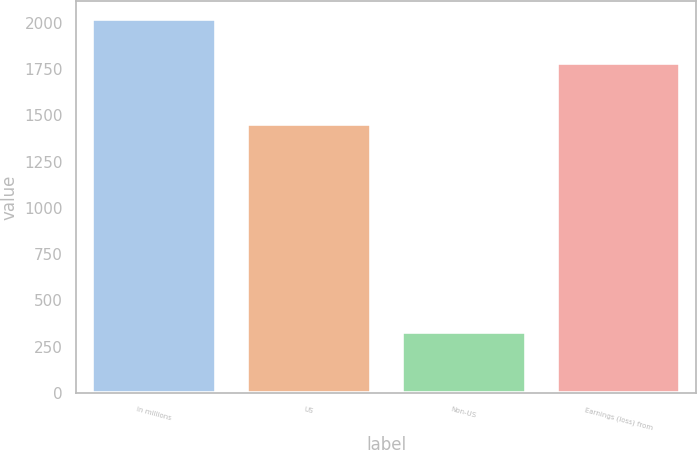Convert chart. <chart><loc_0><loc_0><loc_500><loc_500><bar_chart><fcel>In millions<fcel>US<fcel>Non-US<fcel>Earnings (loss) from<nl><fcel>2018<fcel>1450<fcel>331<fcel>1781<nl></chart> 